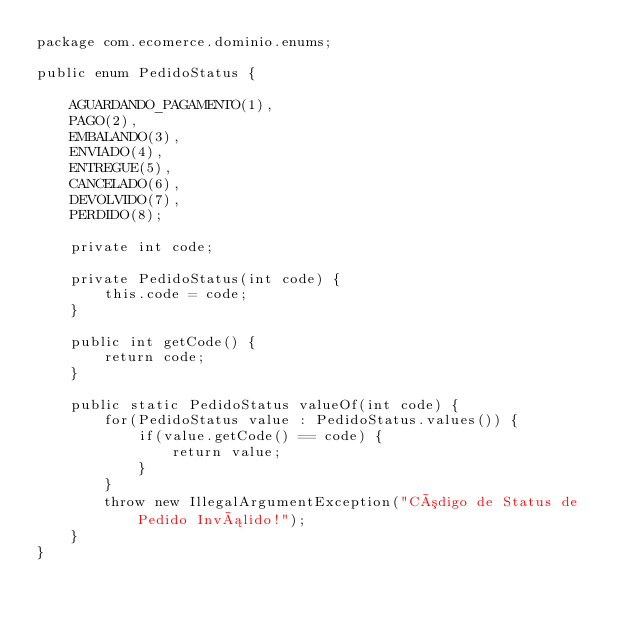<code> <loc_0><loc_0><loc_500><loc_500><_Java_>package com.ecomerce.dominio.enums;

public enum PedidoStatus {
	
	AGUARDANDO_PAGAMENTO(1), 
	PAGO(2), 
	EMBALANDO(3),
	ENVIADO(4),
	ENTREGUE(5),
	CANCELADO(6),
	DEVOLVIDO(7),
	PERDIDO(8);
	
	private int code;
	
	private PedidoStatus(int code) {
		this.code = code;
	}
	
	public int getCode() {
		return code;
	}
	
	public static PedidoStatus valueOf(int code) {
		for(PedidoStatus value : PedidoStatus.values()) {
			if(value.getCode() == code) {
				return value;
			}
		}
		throw new IllegalArgumentException("Código de Status de Pedido Inválido!");
	}
}
</code> 